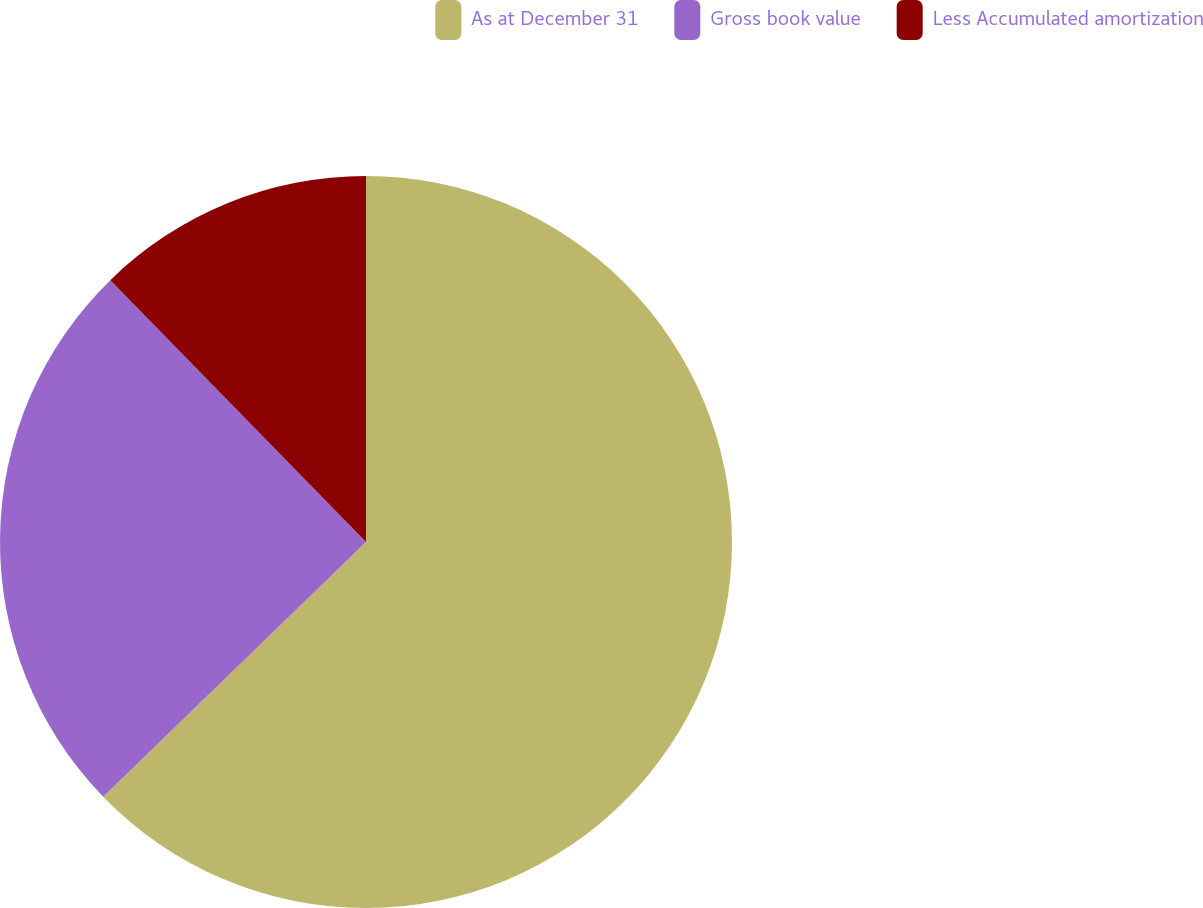Convert chart. <chart><loc_0><loc_0><loc_500><loc_500><pie_chart><fcel>As at December 31<fcel>Gross book value<fcel>Less Accumulated amortization<nl><fcel>62.75%<fcel>24.94%<fcel>12.31%<nl></chart> 